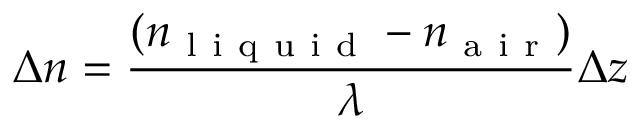Convert formula to latex. <formula><loc_0><loc_0><loc_500><loc_500>\Delta n = \frac { ( n _ { l i q u i d } - n _ { a i r } ) } { \lambda } \Delta z</formula> 